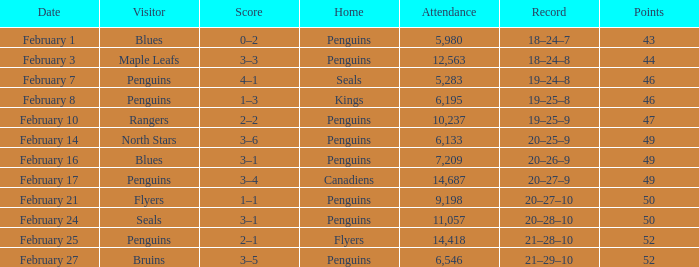Record of 21–29–10 had what total number of points? 1.0. 